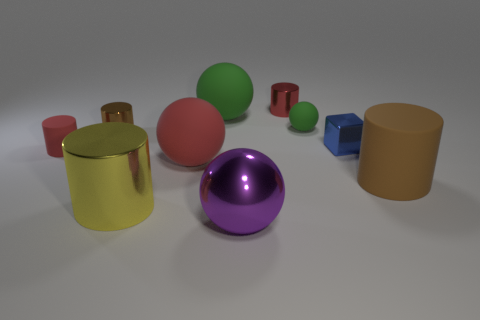Subtract all large metallic spheres. How many spheres are left? 3 Subtract all brown cylinders. How many cylinders are left? 3 Subtract 0 green cubes. How many objects are left? 10 Subtract all blocks. How many objects are left? 9 Subtract 5 cylinders. How many cylinders are left? 0 Subtract all purple cylinders. Subtract all purple balls. How many cylinders are left? 5 Subtract all cyan cylinders. How many blue spheres are left? 0 Subtract all tiny green rubber things. Subtract all small red matte cylinders. How many objects are left? 8 Add 3 big green rubber spheres. How many big green rubber spheres are left? 4 Add 7 red rubber things. How many red rubber things exist? 9 